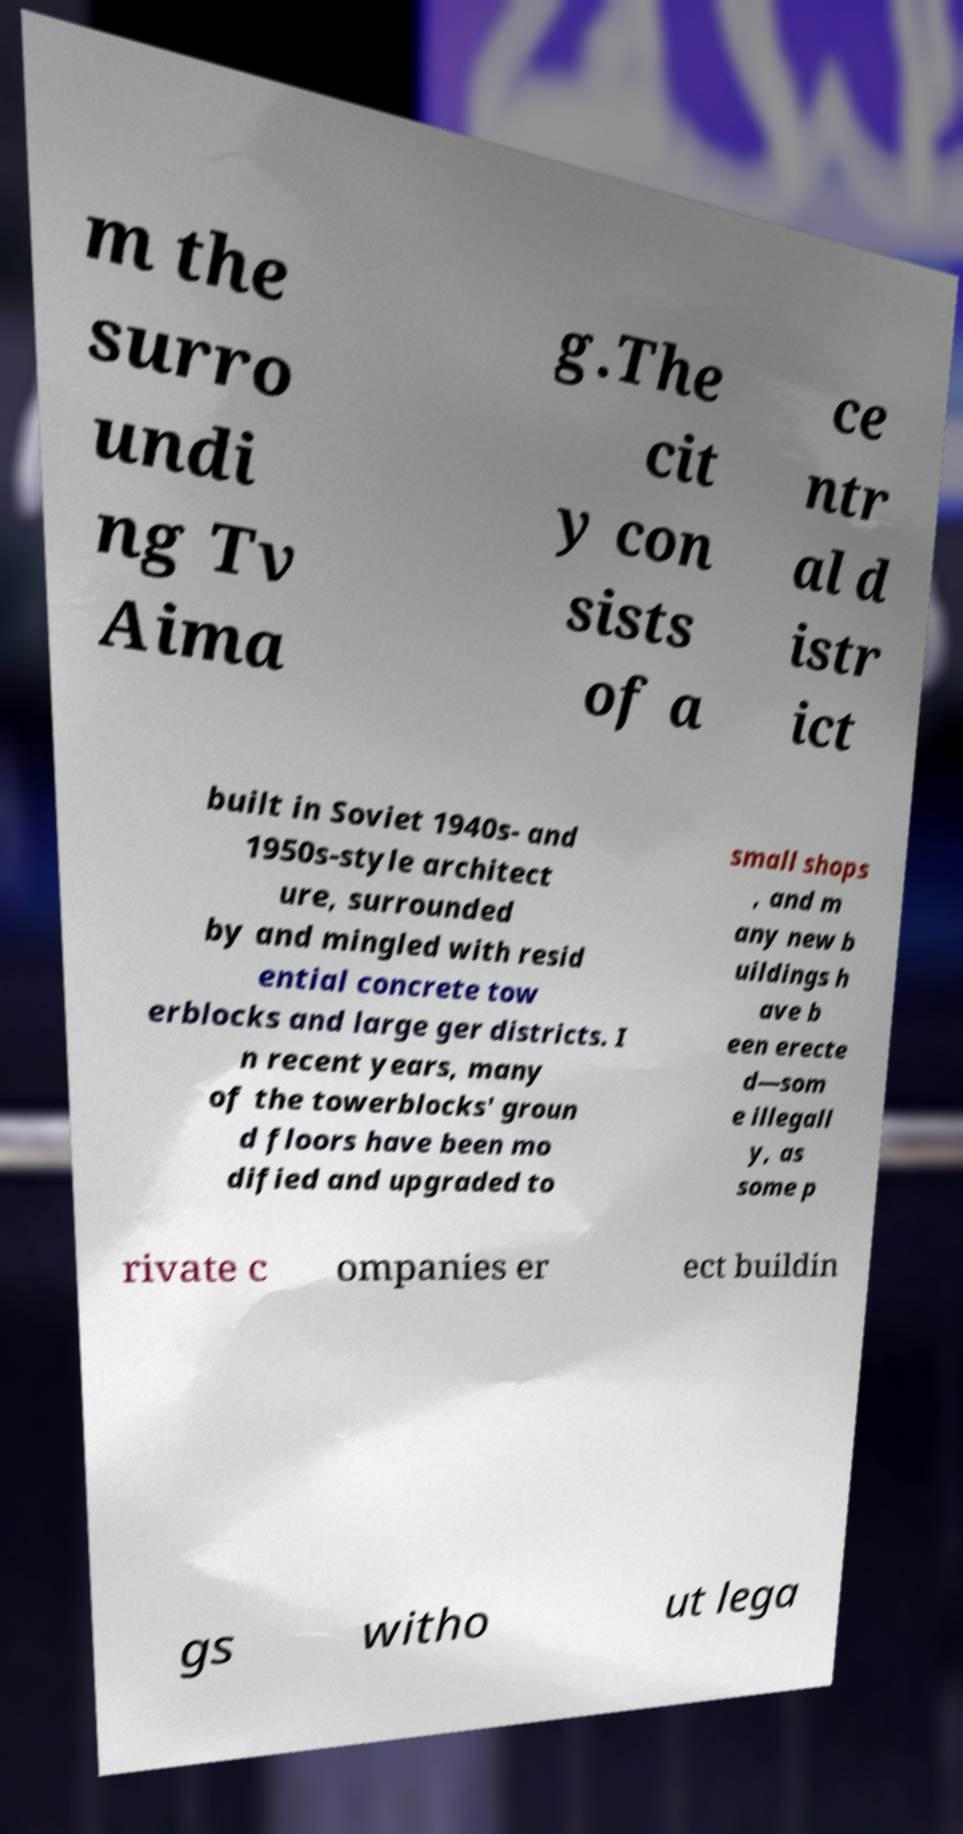What messages or text are displayed in this image? I need them in a readable, typed format. m the surro undi ng Tv Aima g.The cit y con sists of a ce ntr al d istr ict built in Soviet 1940s- and 1950s-style architect ure, surrounded by and mingled with resid ential concrete tow erblocks and large ger districts. I n recent years, many of the towerblocks' groun d floors have been mo dified and upgraded to small shops , and m any new b uildings h ave b een erecte d—som e illegall y, as some p rivate c ompanies er ect buildin gs witho ut lega 